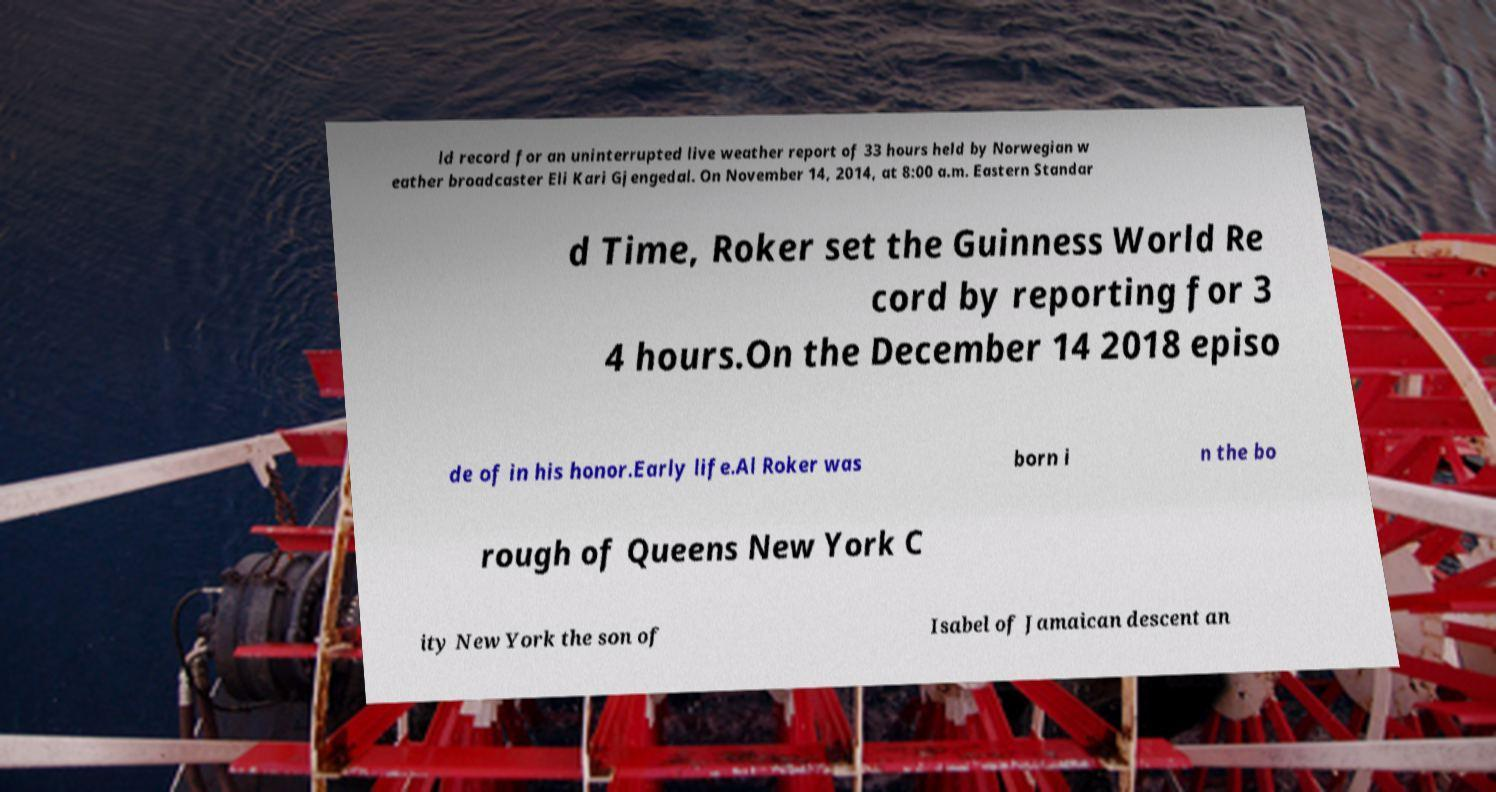I need the written content from this picture converted into text. Can you do that? ld record for an uninterrupted live weather report of 33 hours held by Norwegian w eather broadcaster Eli Kari Gjengedal. On November 14, 2014, at 8:00 a.m. Eastern Standar d Time, Roker set the Guinness World Re cord by reporting for 3 4 hours.On the December 14 2018 episo de of in his honor.Early life.Al Roker was born i n the bo rough of Queens New York C ity New York the son of Isabel of Jamaican descent an 